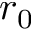Convert formula to latex. <formula><loc_0><loc_0><loc_500><loc_500>r _ { 0 }</formula> 